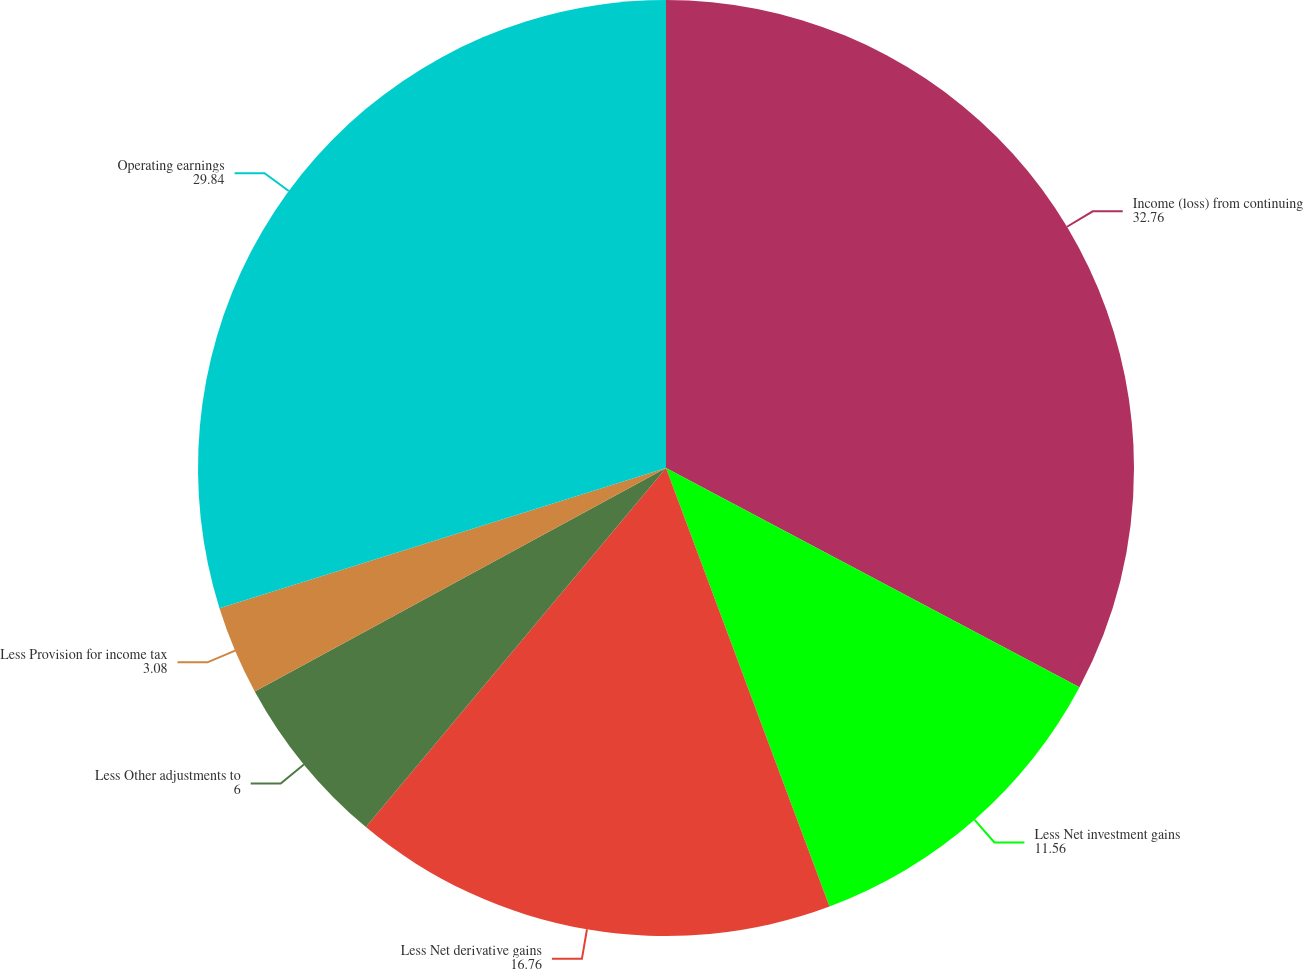<chart> <loc_0><loc_0><loc_500><loc_500><pie_chart><fcel>Income (loss) from continuing<fcel>Less Net investment gains<fcel>Less Net derivative gains<fcel>Less Other adjustments to<fcel>Less Provision for income tax<fcel>Operating earnings<nl><fcel>32.76%<fcel>11.56%<fcel>16.76%<fcel>6.0%<fcel>3.08%<fcel>29.84%<nl></chart> 